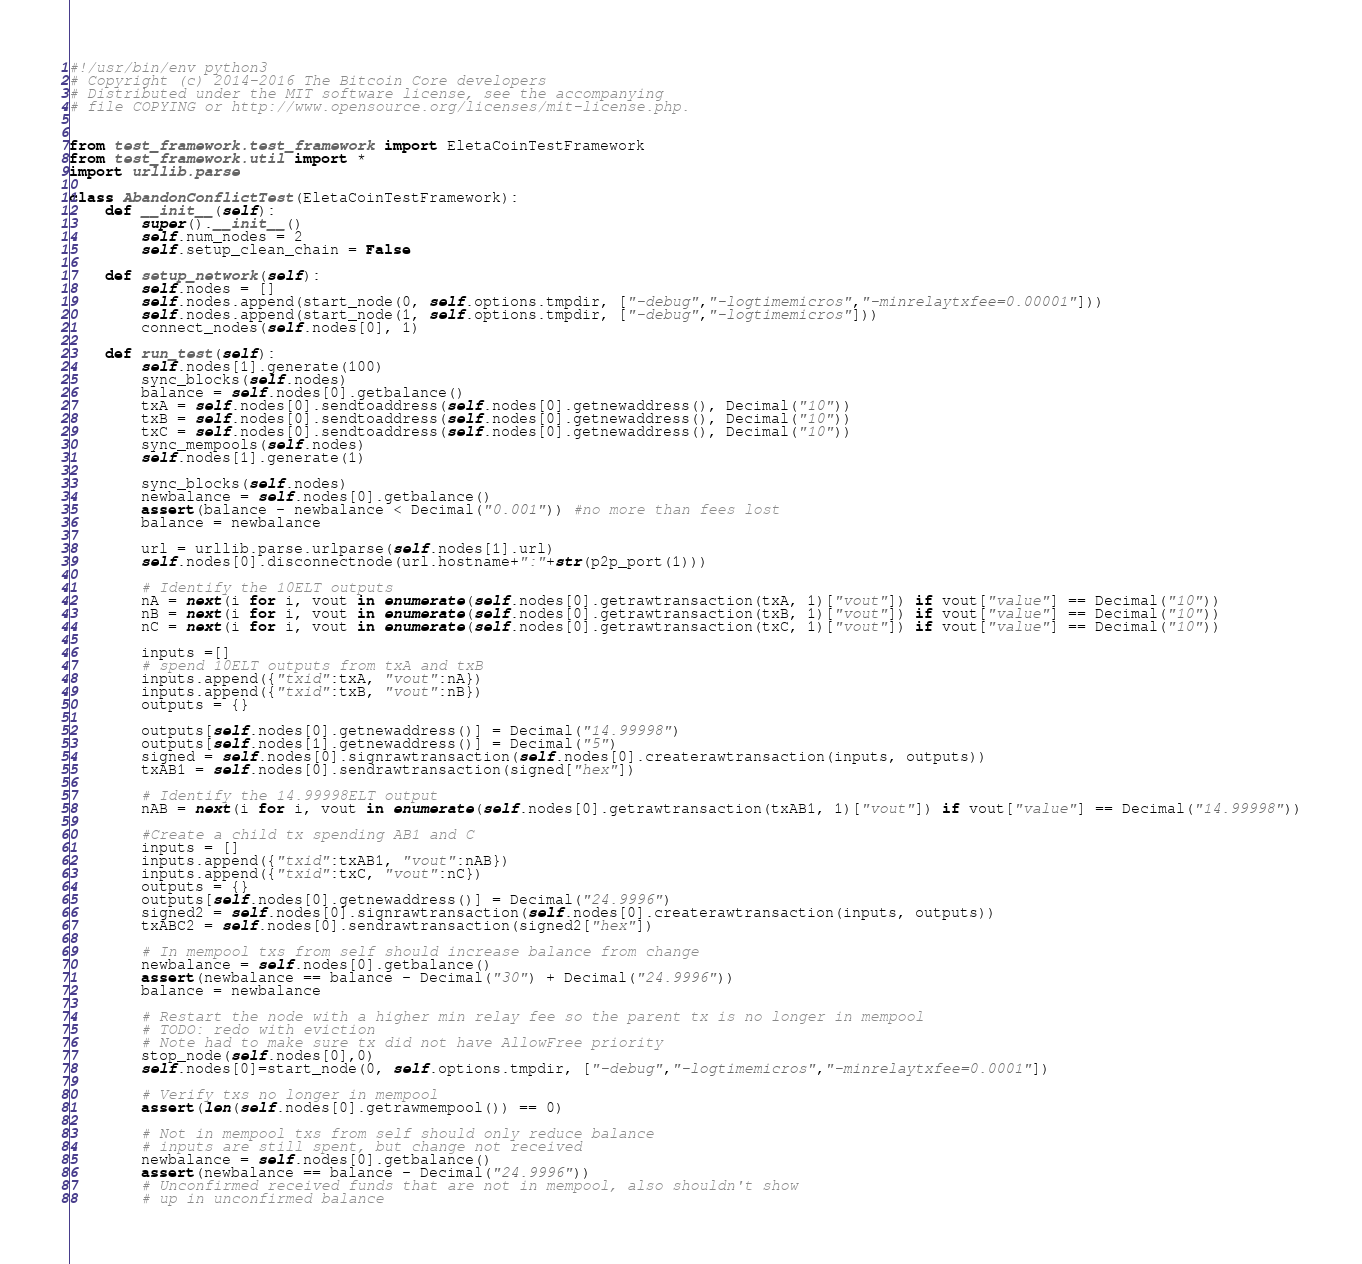<code> <loc_0><loc_0><loc_500><loc_500><_Python_>#!/usr/bin/env python3
# Copyright (c) 2014-2016 The Bitcoin Core developers
# Distributed under the MIT software license, see the accompanying
# file COPYING or http://www.opensource.org/licenses/mit-license.php.


from test_framework.test_framework import EletaCoinTestFramework
from test_framework.util import *
import urllib.parse

class AbandonConflictTest(EletaCoinTestFramework):
    def __init__(self):
        super().__init__()
        self.num_nodes = 2
        self.setup_clean_chain = False

    def setup_network(self):
        self.nodes = []
        self.nodes.append(start_node(0, self.options.tmpdir, ["-debug","-logtimemicros","-minrelaytxfee=0.00001"]))
        self.nodes.append(start_node(1, self.options.tmpdir, ["-debug","-logtimemicros"]))
        connect_nodes(self.nodes[0], 1)

    def run_test(self):
        self.nodes[1].generate(100)
        sync_blocks(self.nodes)
        balance = self.nodes[0].getbalance()
        txA = self.nodes[0].sendtoaddress(self.nodes[0].getnewaddress(), Decimal("10"))
        txB = self.nodes[0].sendtoaddress(self.nodes[0].getnewaddress(), Decimal("10"))
        txC = self.nodes[0].sendtoaddress(self.nodes[0].getnewaddress(), Decimal("10"))
        sync_mempools(self.nodes)
        self.nodes[1].generate(1)

        sync_blocks(self.nodes)
        newbalance = self.nodes[0].getbalance()
        assert(balance - newbalance < Decimal("0.001")) #no more than fees lost
        balance = newbalance

        url = urllib.parse.urlparse(self.nodes[1].url)
        self.nodes[0].disconnectnode(url.hostname+":"+str(p2p_port(1)))

        # Identify the 10ELT outputs
        nA = next(i for i, vout in enumerate(self.nodes[0].getrawtransaction(txA, 1)["vout"]) if vout["value"] == Decimal("10"))
        nB = next(i for i, vout in enumerate(self.nodes[0].getrawtransaction(txB, 1)["vout"]) if vout["value"] == Decimal("10"))
        nC = next(i for i, vout in enumerate(self.nodes[0].getrawtransaction(txC, 1)["vout"]) if vout["value"] == Decimal("10"))

        inputs =[]
        # spend 10ELT outputs from txA and txB
        inputs.append({"txid":txA, "vout":nA})
        inputs.append({"txid":txB, "vout":nB})
        outputs = {}

        outputs[self.nodes[0].getnewaddress()] = Decimal("14.99998")
        outputs[self.nodes[1].getnewaddress()] = Decimal("5")
        signed = self.nodes[0].signrawtransaction(self.nodes[0].createrawtransaction(inputs, outputs))
        txAB1 = self.nodes[0].sendrawtransaction(signed["hex"])

        # Identify the 14.99998ELT output
        nAB = next(i for i, vout in enumerate(self.nodes[0].getrawtransaction(txAB1, 1)["vout"]) if vout["value"] == Decimal("14.99998"))

        #Create a child tx spending AB1 and C
        inputs = []
        inputs.append({"txid":txAB1, "vout":nAB})
        inputs.append({"txid":txC, "vout":nC})
        outputs = {}
        outputs[self.nodes[0].getnewaddress()] = Decimal("24.9996")
        signed2 = self.nodes[0].signrawtransaction(self.nodes[0].createrawtransaction(inputs, outputs))
        txABC2 = self.nodes[0].sendrawtransaction(signed2["hex"])

        # In mempool txs from self should increase balance from change
        newbalance = self.nodes[0].getbalance()
        assert(newbalance == balance - Decimal("30") + Decimal("24.9996"))
        balance = newbalance

        # Restart the node with a higher min relay fee so the parent tx is no longer in mempool
        # TODO: redo with eviction
        # Note had to make sure tx did not have AllowFree priority
        stop_node(self.nodes[0],0)
        self.nodes[0]=start_node(0, self.options.tmpdir, ["-debug","-logtimemicros","-minrelaytxfee=0.0001"])

        # Verify txs no longer in mempool
        assert(len(self.nodes[0].getrawmempool()) == 0)

        # Not in mempool txs from self should only reduce balance
        # inputs are still spent, but change not received
        newbalance = self.nodes[0].getbalance()
        assert(newbalance == balance - Decimal("24.9996"))
        # Unconfirmed received funds that are not in mempool, also shouldn't show
        # up in unconfirmed balance</code> 